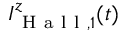Convert formula to latex. <formula><loc_0><loc_0><loc_500><loc_500>I _ { H a l l , 1 } ^ { z } ( t )</formula> 